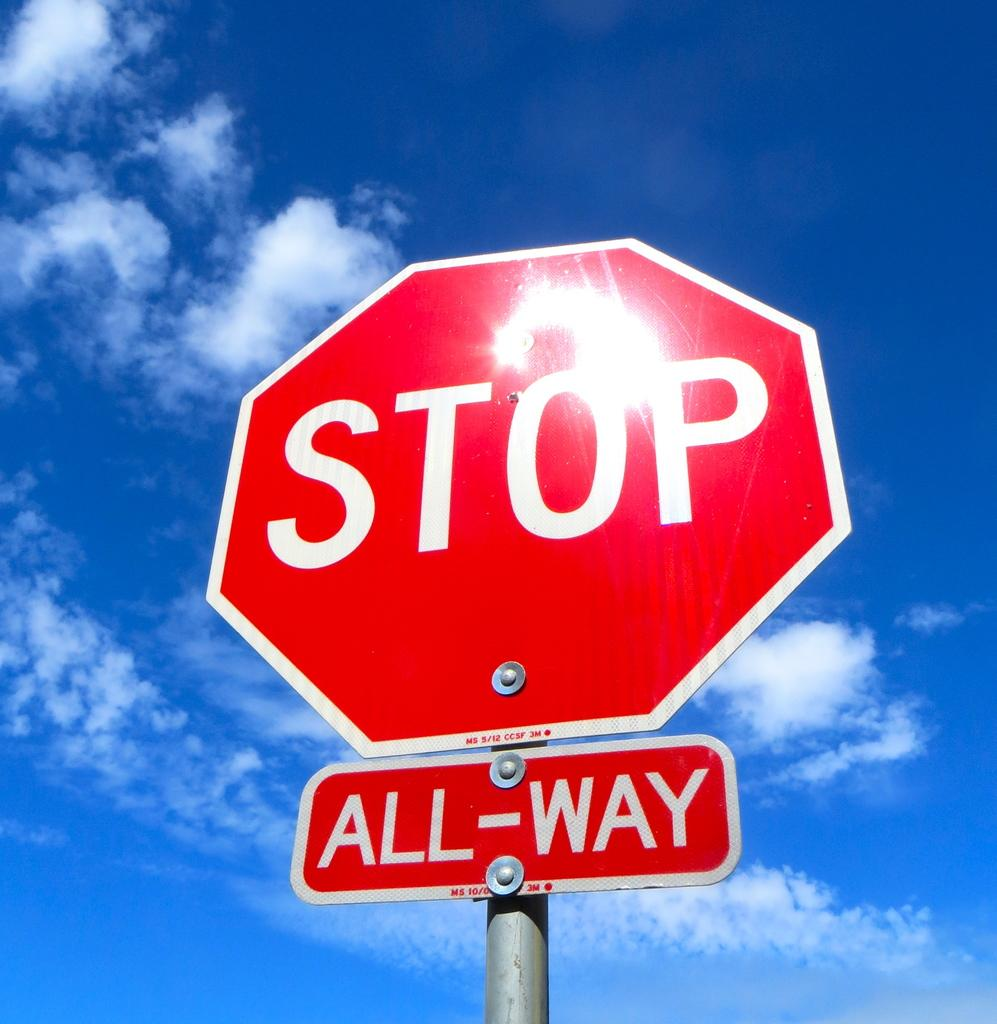<image>
Render a clear and concise summary of the photo. A stop sign above an All-Way sign with the sky in the background. 